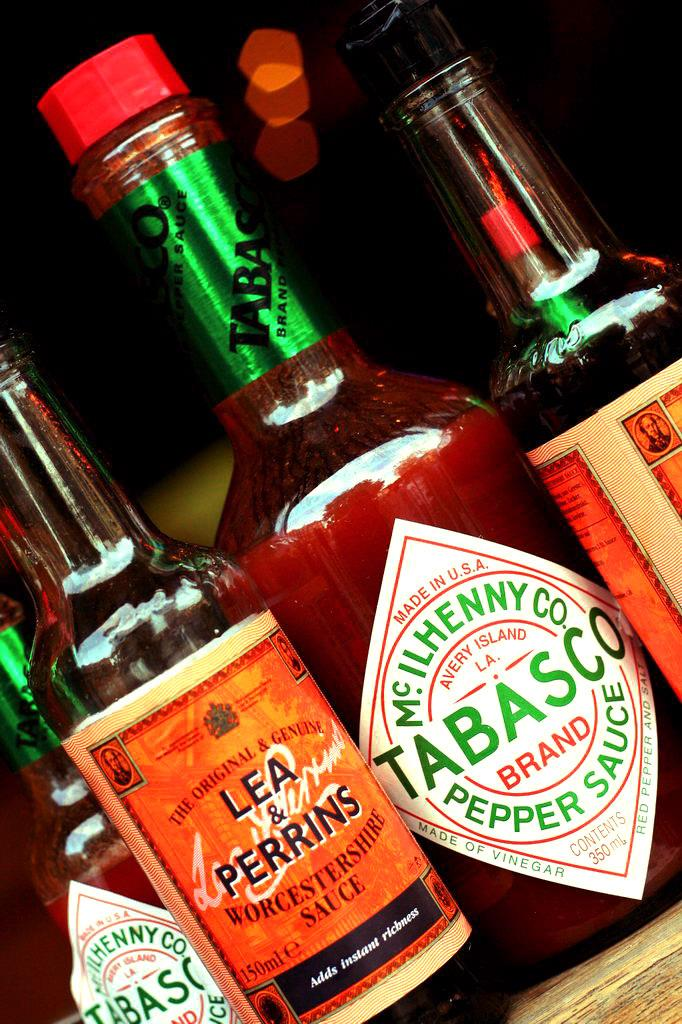Provide a one-sentence caption for the provided image. A bottle of Tabasco sits among other condiments. 